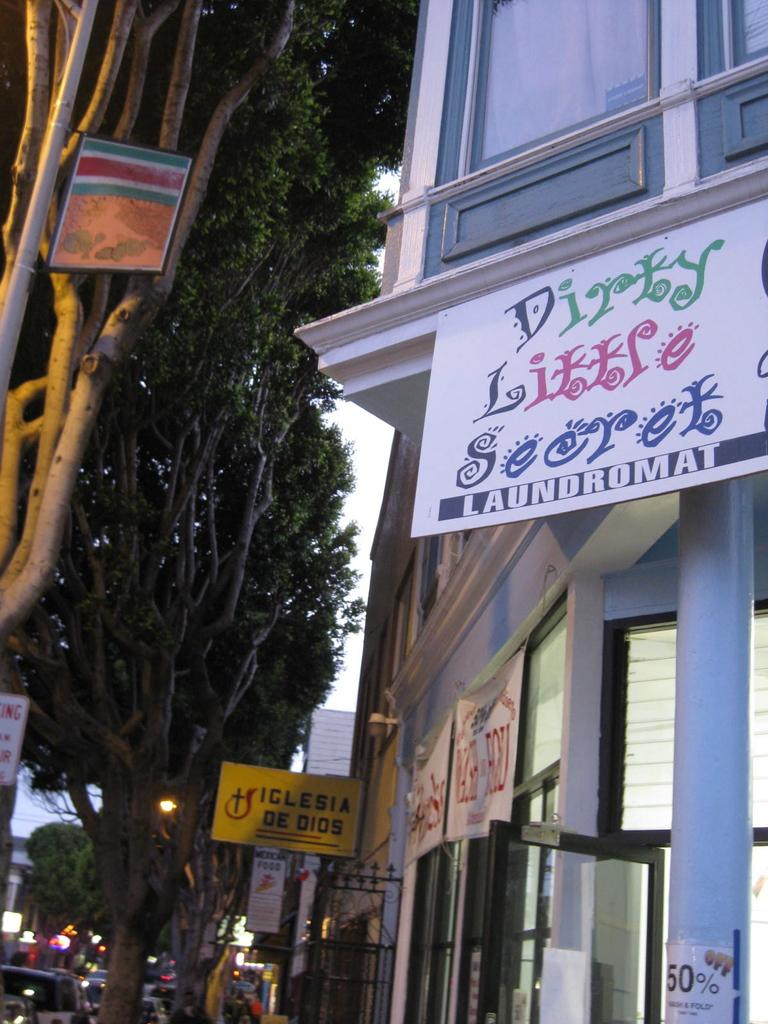What is located in the center of the image? There are trees in the center of the image. What structure can be seen on the right side of the image? There is a building on the right side of the image. What is on the building? There is a board on the building. What type of vehicles can be seen at the bottom of the image? Cars are visible at the bottom of the image. Can you tell me how many books the judge is holding in the image? There is no judge or books present in the image. Is there a squirrel visible on the board in the image? There is no squirrel present in the image. 